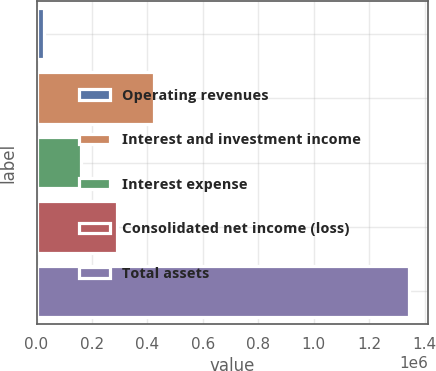Convert chart. <chart><loc_0><loc_0><loc_500><loc_500><bar_chart><fcel>Operating revenues<fcel>Interest and investment income<fcel>Interest expense<fcel>Consolidated net income (loss)<fcel>Total assets<nl><fcel>27155<fcel>422030<fcel>158780<fcel>290405<fcel>1.34341e+06<nl></chart> 